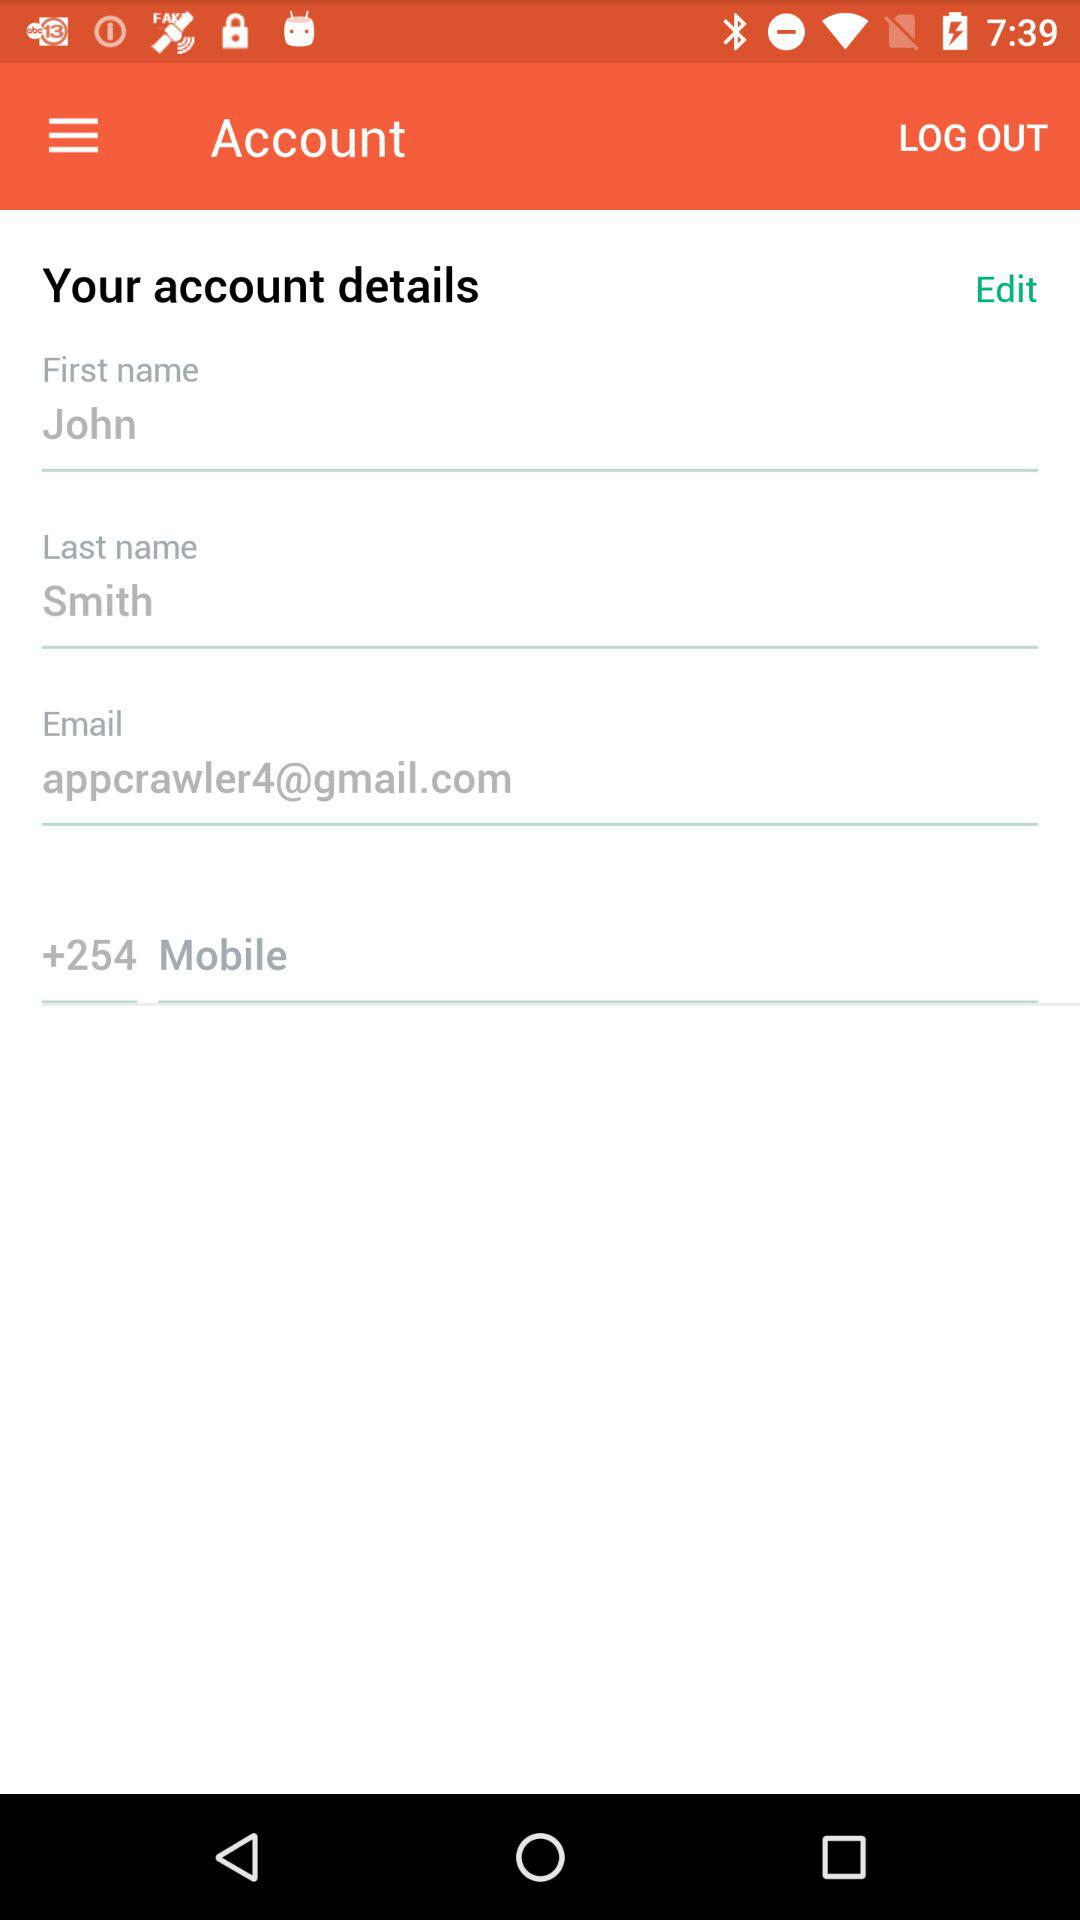What is the first name? The first name is John. 